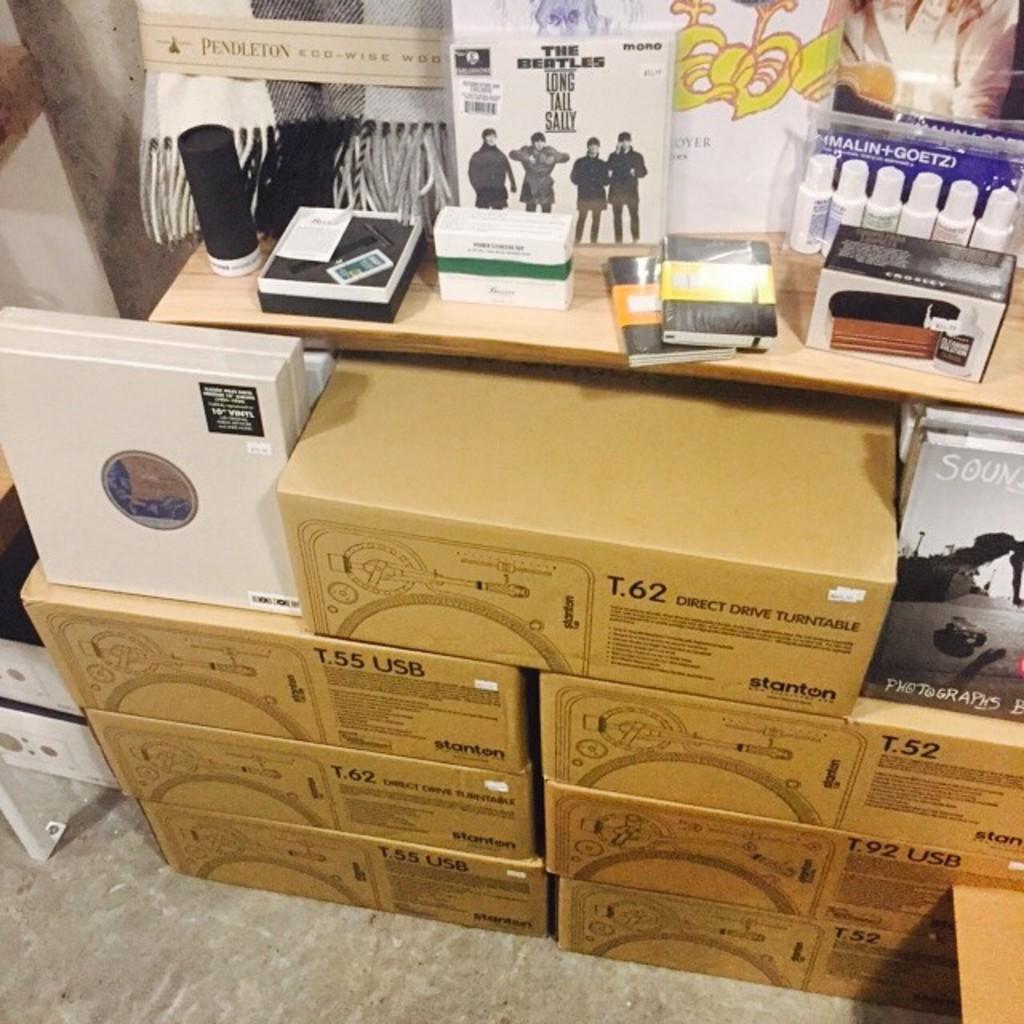Please provide a concise description of this image. Here we can able to see number of cardboard boxes. Above this cardboard boxes there are bottles, books and box. 